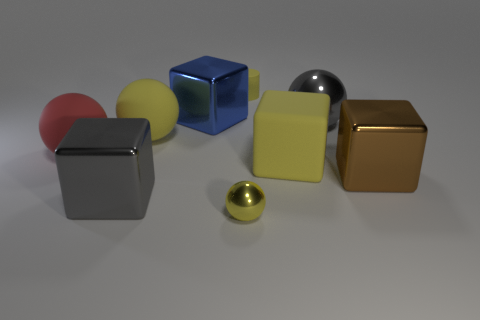Is there anything else that is the same color as the rubber block?
Provide a succinct answer. Yes. There is a thing that is the same color as the big shiny ball; what is its shape?
Provide a succinct answer. Cube. There is a rubber sphere right of the red rubber object; is it the same color as the shiny ball to the left of the tiny yellow matte cylinder?
Your response must be concise. Yes. There is a cylinder that is the same color as the small sphere; what size is it?
Your answer should be compact. Small. Are there more spheres than objects?
Your answer should be very brief. No. There is a tiny thing in front of the big yellow block; does it have the same color as the cylinder?
Provide a short and direct response. Yes. What number of objects are either large metallic objects that are on the left side of the big yellow rubber cube or big gray things left of the small yellow matte thing?
Ensure brevity in your answer.  2. How many big balls are both to the right of the red rubber ball and to the left of the cylinder?
Your answer should be very brief. 1. Is the material of the tiny ball the same as the brown object?
Make the answer very short. Yes. What is the shape of the tiny yellow object that is in front of the cube behind the large yellow matte thing that is on the right side of the large blue shiny object?
Offer a very short reply. Sphere. 